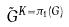Convert formula to latex. <formula><loc_0><loc_0><loc_500><loc_500>\tilde { G } ^ { K = \pi _ { 1 } ( G ) }</formula> 